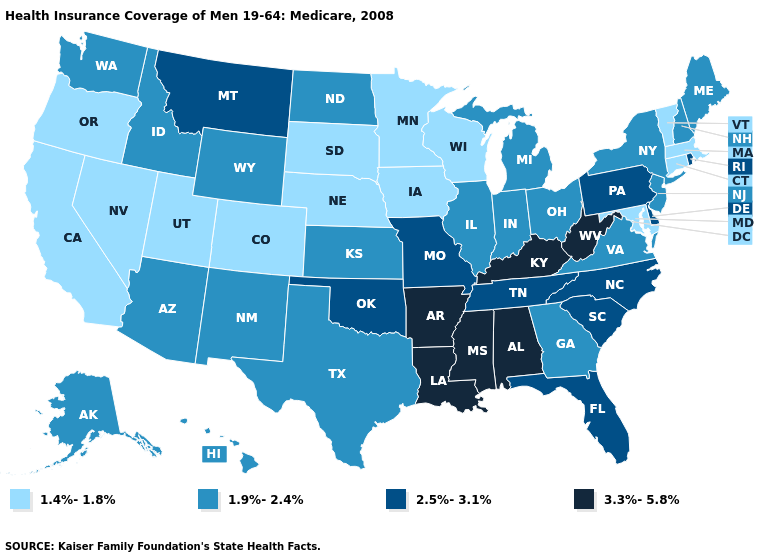Which states have the lowest value in the USA?
Quick response, please. California, Colorado, Connecticut, Iowa, Maryland, Massachusetts, Minnesota, Nebraska, Nevada, Oregon, South Dakota, Utah, Vermont, Wisconsin. Which states have the lowest value in the West?
Short answer required. California, Colorado, Nevada, Oregon, Utah. Does Colorado have the lowest value in the West?
Give a very brief answer. Yes. What is the value of Florida?
Quick response, please. 2.5%-3.1%. Name the states that have a value in the range 1.9%-2.4%?
Answer briefly. Alaska, Arizona, Georgia, Hawaii, Idaho, Illinois, Indiana, Kansas, Maine, Michigan, New Hampshire, New Jersey, New Mexico, New York, North Dakota, Ohio, Texas, Virginia, Washington, Wyoming. Does Idaho have the highest value in the USA?
Concise answer only. No. What is the lowest value in states that border Montana?
Answer briefly. 1.4%-1.8%. Does Hawaii have a higher value than Arkansas?
Write a very short answer. No. Name the states that have a value in the range 3.3%-5.8%?
Write a very short answer. Alabama, Arkansas, Kentucky, Louisiana, Mississippi, West Virginia. Does Maryland have the lowest value in the USA?
Give a very brief answer. Yes. What is the lowest value in the Northeast?
Concise answer only. 1.4%-1.8%. Does the map have missing data?
Short answer required. No. Name the states that have a value in the range 2.5%-3.1%?
Concise answer only. Delaware, Florida, Missouri, Montana, North Carolina, Oklahoma, Pennsylvania, Rhode Island, South Carolina, Tennessee. What is the value of Texas?
Answer briefly. 1.9%-2.4%. Does Pennsylvania have the highest value in the Northeast?
Keep it brief. Yes. 